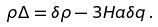<formula> <loc_0><loc_0><loc_500><loc_500>\rho \Delta = \delta \rho - 3 H a \delta q \, .</formula> 